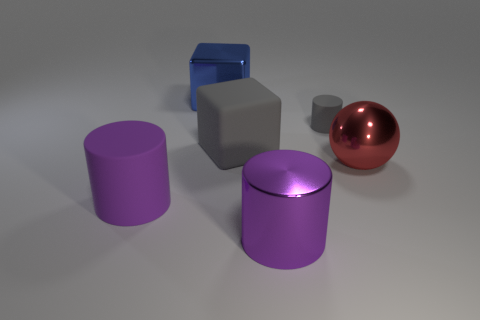Is the number of gray rubber cylinders on the left side of the big gray matte cube the same as the number of blue objects that are in front of the tiny gray object?
Offer a terse response. Yes. Is the cylinder that is behind the red ball made of the same material as the large purple object to the right of the blue cube?
Your response must be concise. No. What is the gray block made of?
Offer a very short reply. Rubber. What number of other objects are the same color as the large shiny ball?
Give a very brief answer. 0. Does the big metallic cylinder have the same color as the large rubber cylinder?
Ensure brevity in your answer.  Yes. How many yellow matte cylinders are there?
Give a very brief answer. 0. The purple cylinder that is in front of the matte cylinder that is in front of the red ball is made of what material?
Your response must be concise. Metal. There is a blue object that is the same size as the red object; what is it made of?
Give a very brief answer. Metal. Do the blue cube on the left side of the metal cylinder and the tiny thing have the same size?
Ensure brevity in your answer.  No. Is the shape of the gray thing to the right of the big purple metal thing the same as  the purple shiny object?
Offer a terse response. Yes. 